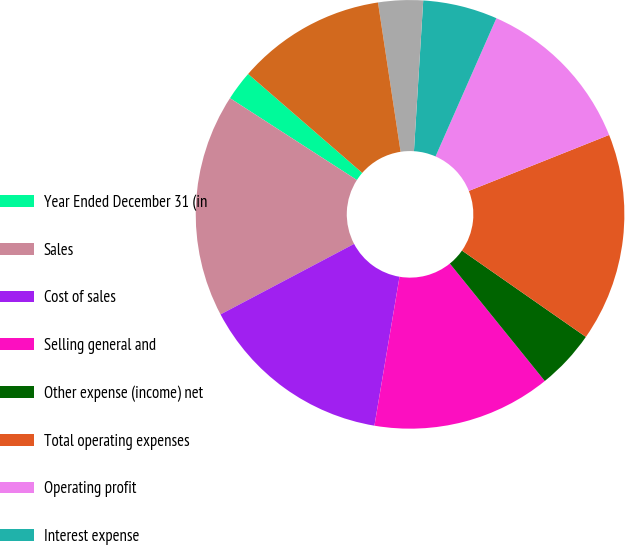Convert chart to OTSL. <chart><loc_0><loc_0><loc_500><loc_500><pie_chart><fcel>Year Ended December 31 (in<fcel>Sales<fcel>Cost of sales<fcel>Selling general and<fcel>Other expense (income) net<fcel>Total operating expenses<fcel>Operating profit<fcel>Interest expense<fcel>Interest income<fcel>Earnings before income taxes<nl><fcel>2.25%<fcel>16.85%<fcel>14.61%<fcel>13.48%<fcel>4.49%<fcel>15.73%<fcel>12.36%<fcel>5.62%<fcel>3.37%<fcel>11.24%<nl></chart> 